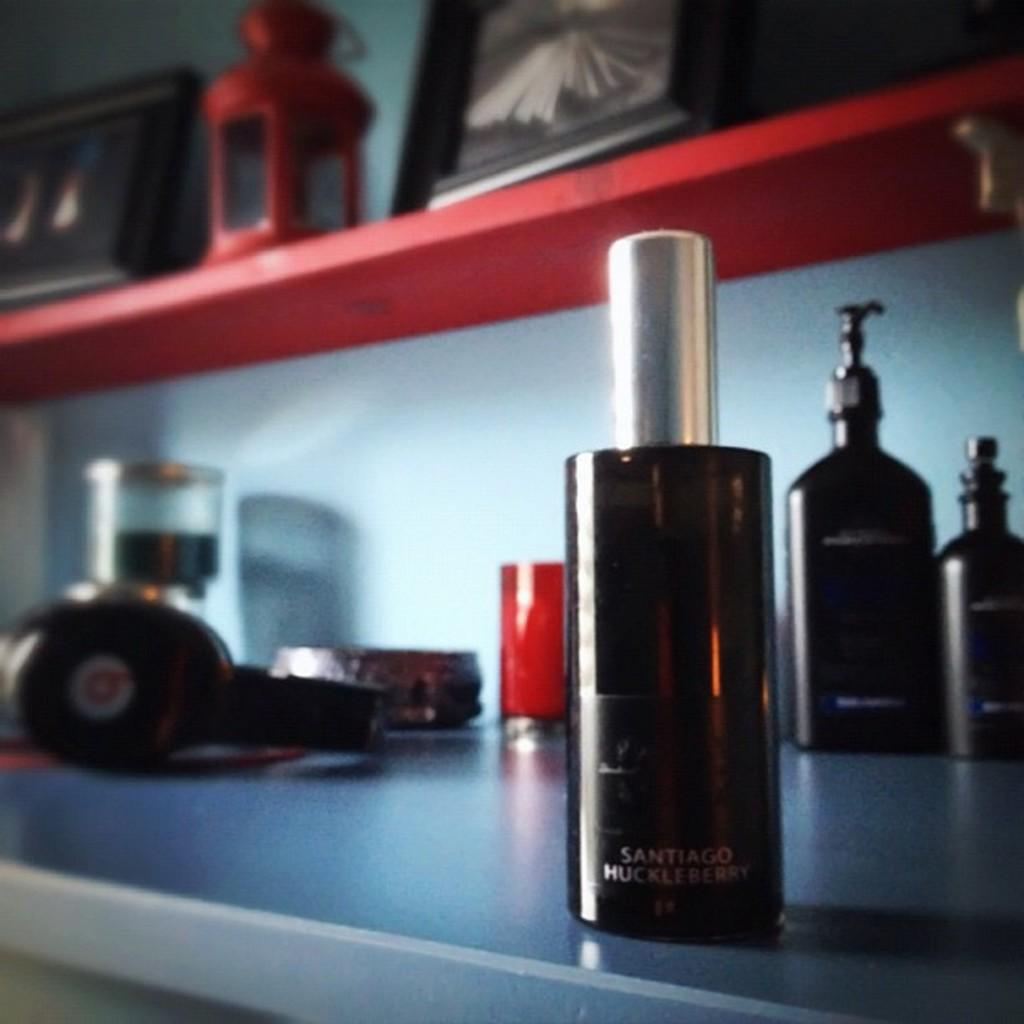<image>
Summarize the visual content of the image. A spray bottle of Santiago Huckleberry sits on a counter along with many other items. 